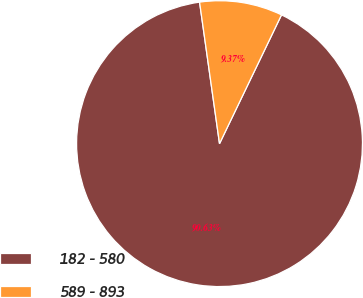<chart> <loc_0><loc_0><loc_500><loc_500><pie_chart><fcel>182 - 580<fcel>589 - 893<nl><fcel>90.63%<fcel>9.37%<nl></chart> 